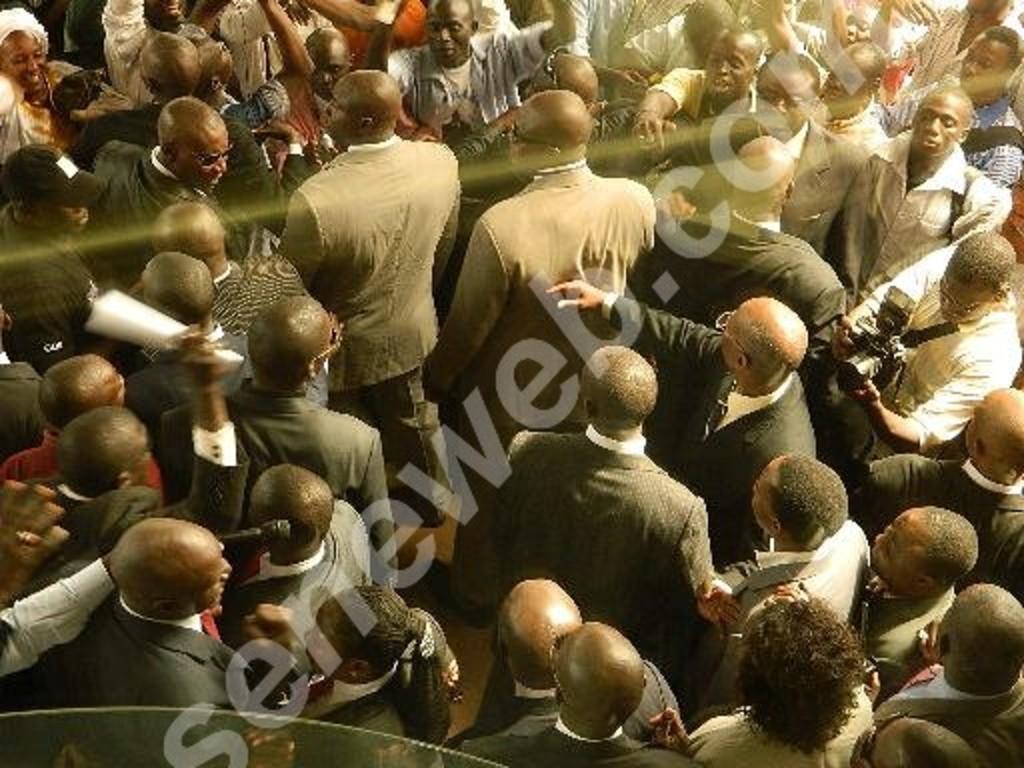Please provide a concise description of this image. This is an edited image. In this image we can see a group of people. In that a man is holding a camera. We can also see some text on the image. 